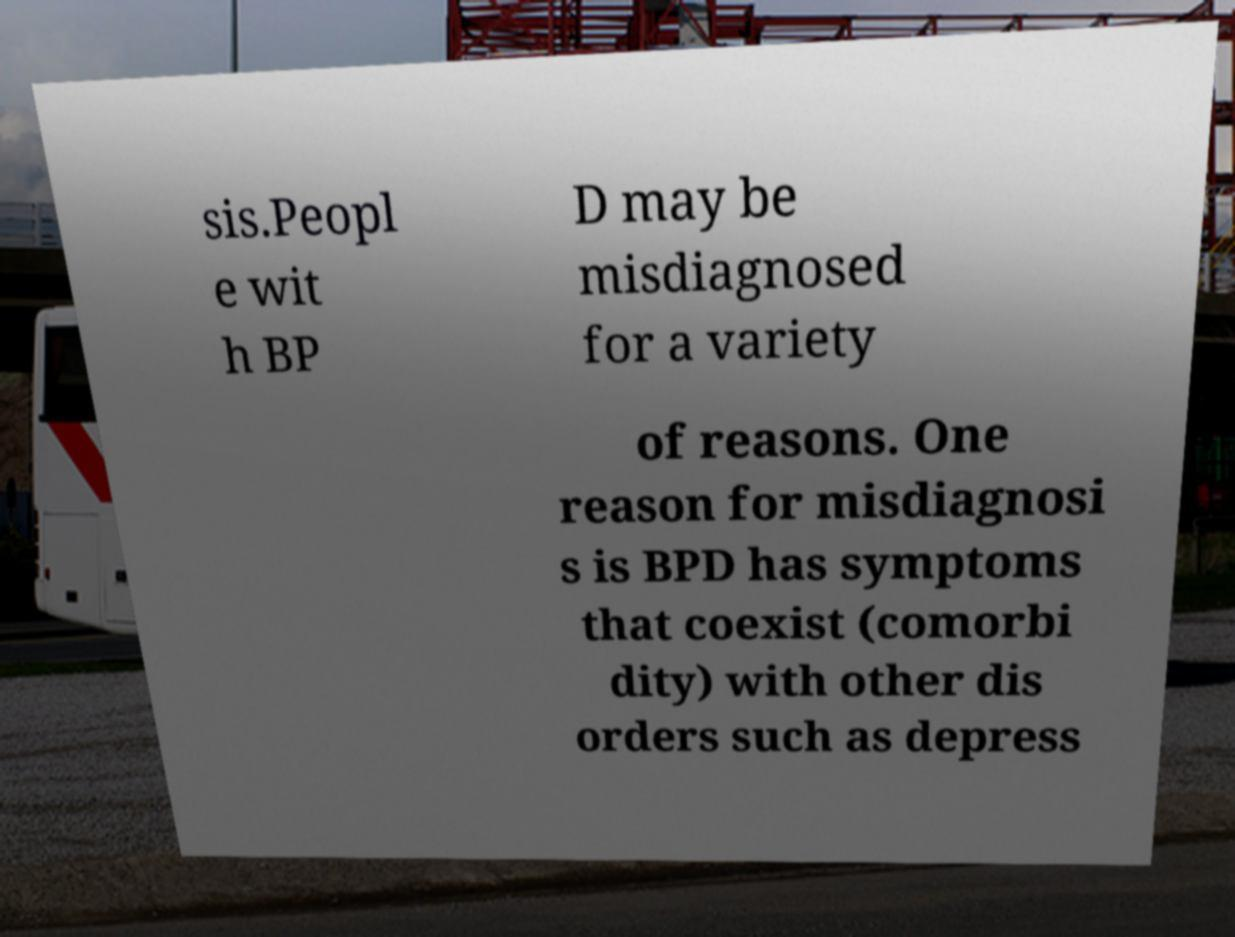Can you accurately transcribe the text from the provided image for me? sis.Peopl e wit h BP D may be misdiagnosed for a variety of reasons. One reason for misdiagnosi s is BPD has symptoms that coexist (comorbi dity) with other dis orders such as depress 